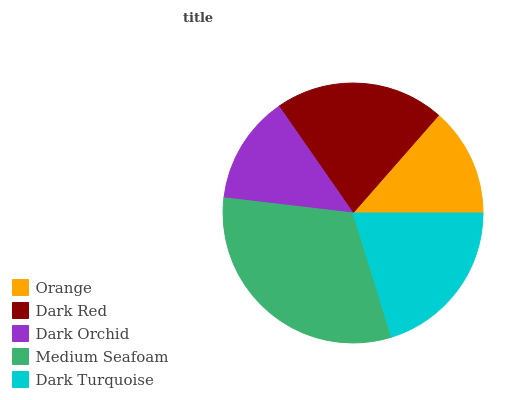Is Dark Orchid the minimum?
Answer yes or no. Yes. Is Medium Seafoam the maximum?
Answer yes or no. Yes. Is Dark Red the minimum?
Answer yes or no. No. Is Dark Red the maximum?
Answer yes or no. No. Is Dark Red greater than Orange?
Answer yes or no. Yes. Is Orange less than Dark Red?
Answer yes or no. Yes. Is Orange greater than Dark Red?
Answer yes or no. No. Is Dark Red less than Orange?
Answer yes or no. No. Is Dark Turquoise the high median?
Answer yes or no. Yes. Is Dark Turquoise the low median?
Answer yes or no. Yes. Is Orange the high median?
Answer yes or no. No. Is Dark Orchid the low median?
Answer yes or no. No. 